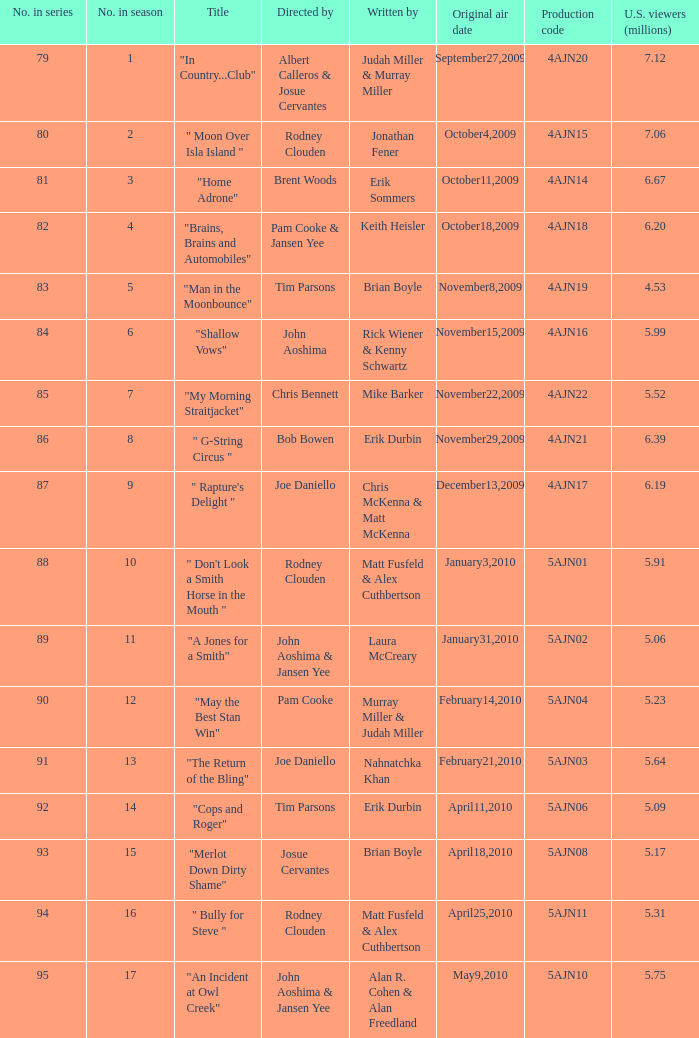Identify the writer of the episode that pam cooke and jansen yee directed. Keith Heisler. 